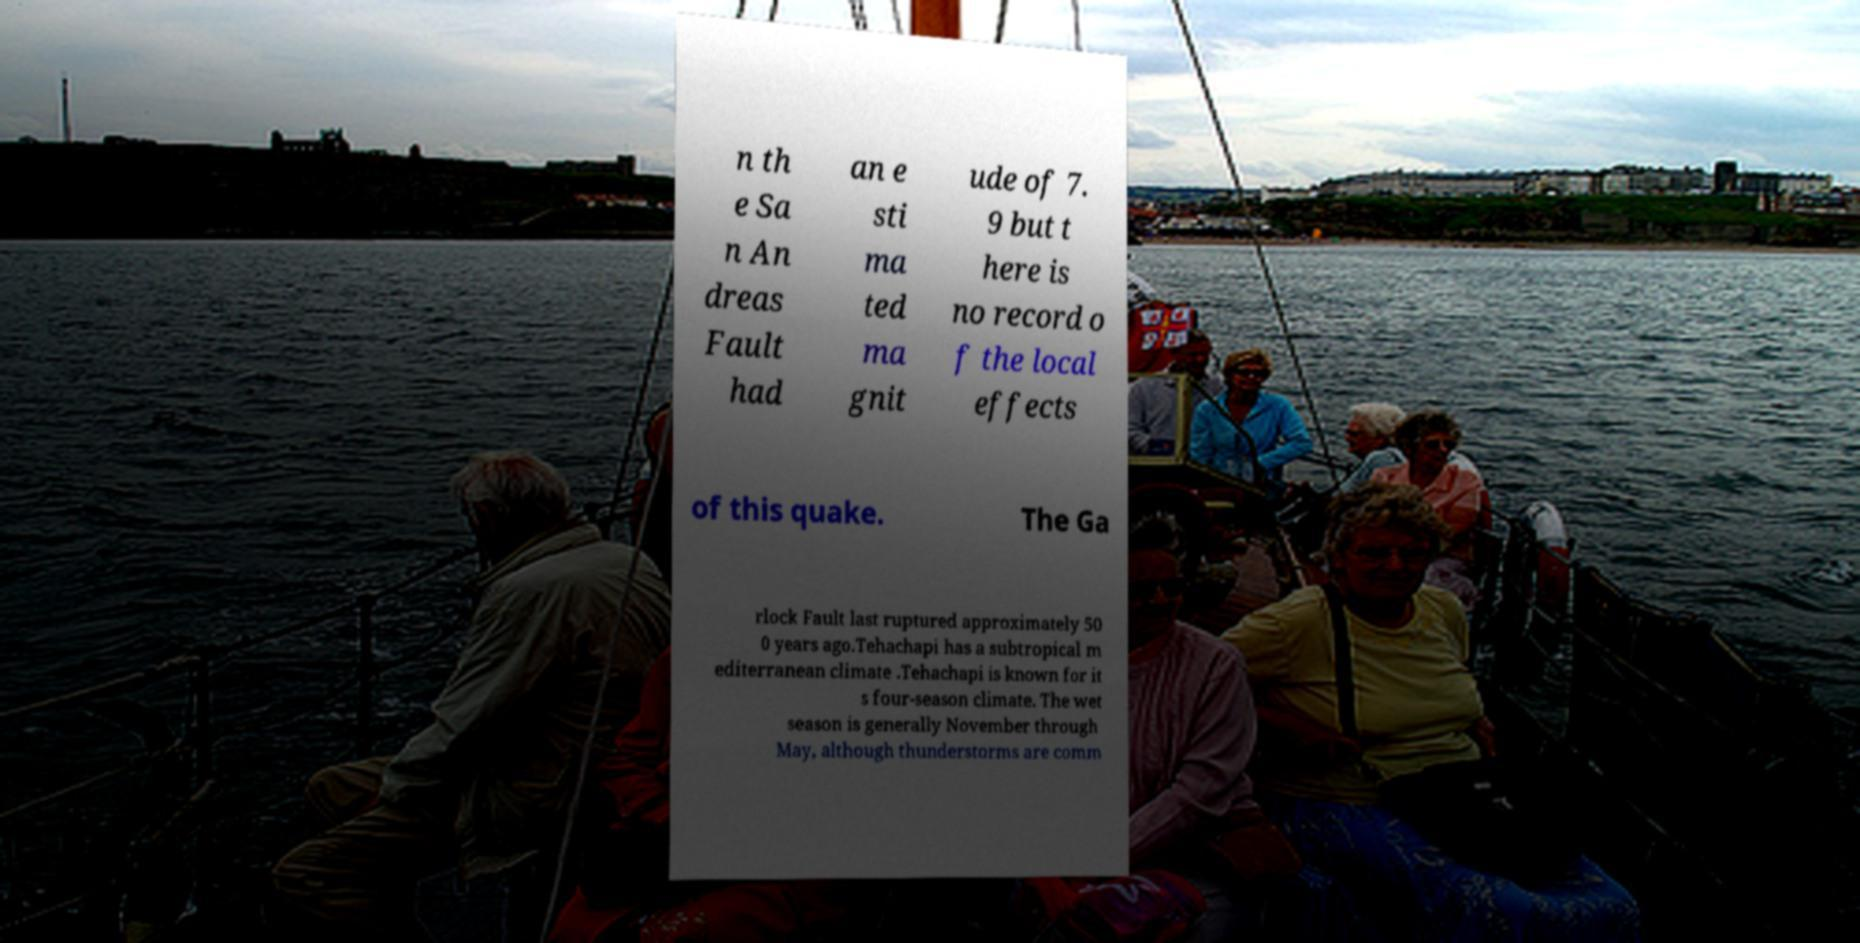Could you extract and type out the text from this image? n th e Sa n An dreas Fault had an e sti ma ted ma gnit ude of 7. 9 but t here is no record o f the local effects of this quake. The Ga rlock Fault last ruptured approximately 50 0 years ago.Tehachapi has a subtropical m editerranean climate .Tehachapi is known for it s four-season climate. The wet season is generally November through May, although thunderstorms are comm 